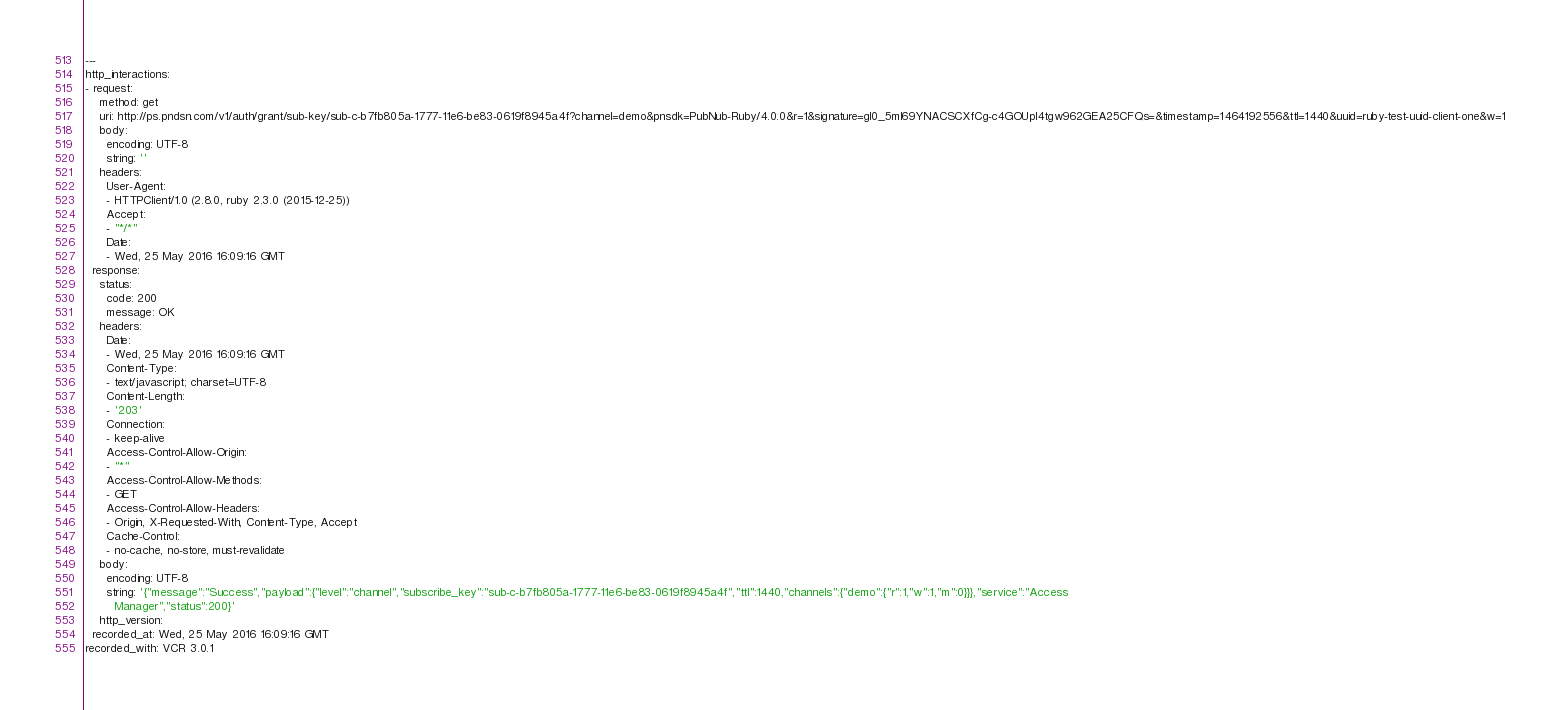Convert code to text. <code><loc_0><loc_0><loc_500><loc_500><_YAML_>---
http_interactions:
- request:
    method: get
    uri: http://ps.pndsn.com/v1/auth/grant/sub-key/sub-c-b7fb805a-1777-11e6-be83-0619f8945a4f?channel=demo&pnsdk=PubNub-Ruby/4.0.0&r=1&signature=gl0_5ml69YNACSCXfCg-c4GOUpl4tgw962GEA25CFQs=&timestamp=1464192556&ttl=1440&uuid=ruby-test-uuid-client-one&w=1
    body:
      encoding: UTF-8
      string: ''
    headers:
      User-Agent:
      - HTTPClient/1.0 (2.8.0, ruby 2.3.0 (2015-12-25))
      Accept:
      - "*/*"
      Date:
      - Wed, 25 May 2016 16:09:16 GMT
  response:
    status:
      code: 200
      message: OK
    headers:
      Date:
      - Wed, 25 May 2016 16:09:16 GMT
      Content-Type:
      - text/javascript; charset=UTF-8
      Content-Length:
      - '203'
      Connection:
      - keep-alive
      Access-Control-Allow-Origin:
      - "*"
      Access-Control-Allow-Methods:
      - GET
      Access-Control-Allow-Headers:
      - Origin, X-Requested-With, Content-Type, Accept
      Cache-Control:
      - no-cache, no-store, must-revalidate
    body:
      encoding: UTF-8
      string: '{"message":"Success","payload":{"level":"channel","subscribe_key":"sub-c-b7fb805a-1777-11e6-be83-0619f8945a4f","ttl":1440,"channels":{"demo":{"r":1,"w":1,"m":0}}},"service":"Access
        Manager","status":200}'
    http_version: 
  recorded_at: Wed, 25 May 2016 16:09:16 GMT
recorded_with: VCR 3.0.1
</code> 